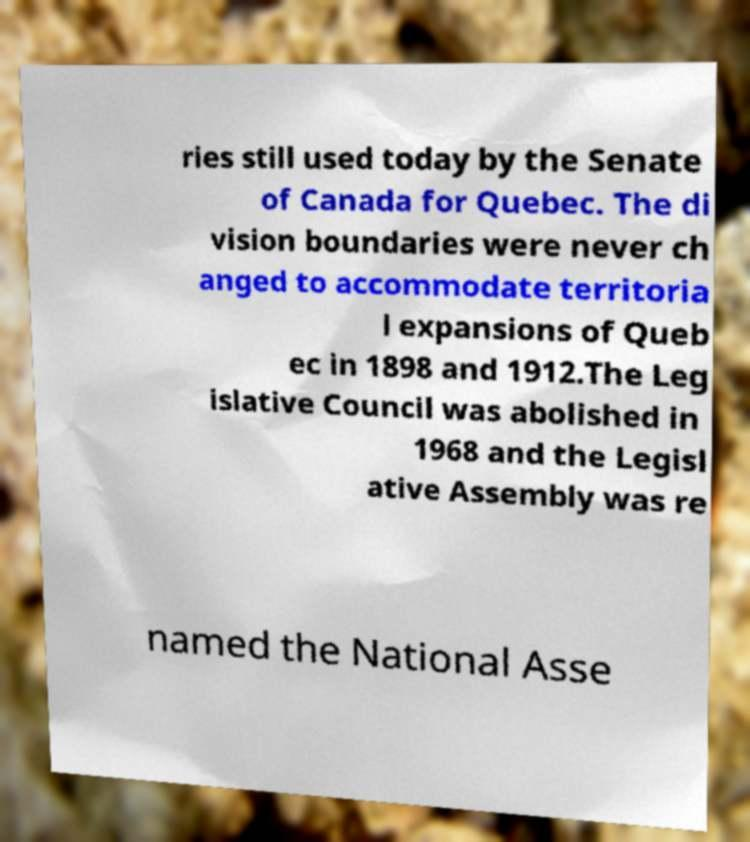Can you read and provide the text displayed in the image?This photo seems to have some interesting text. Can you extract and type it out for me? ries still used today by the Senate of Canada for Quebec. The di vision boundaries were never ch anged to accommodate territoria l expansions of Queb ec in 1898 and 1912.The Leg islative Council was abolished in 1968 and the Legisl ative Assembly was re named the National Asse 